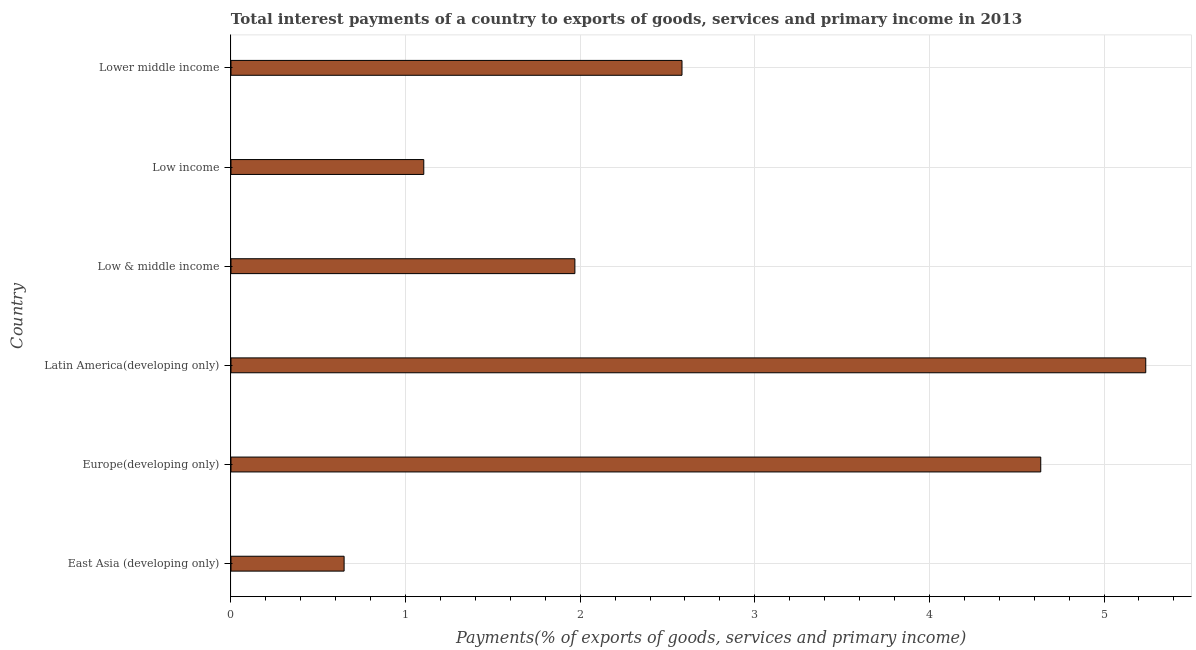Does the graph contain any zero values?
Your response must be concise. No. What is the title of the graph?
Offer a terse response. Total interest payments of a country to exports of goods, services and primary income in 2013. What is the label or title of the X-axis?
Provide a succinct answer. Payments(% of exports of goods, services and primary income). What is the label or title of the Y-axis?
Provide a short and direct response. Country. What is the total interest payments on external debt in Latin America(developing only)?
Keep it short and to the point. 5.24. Across all countries, what is the maximum total interest payments on external debt?
Make the answer very short. 5.24. Across all countries, what is the minimum total interest payments on external debt?
Your answer should be very brief. 0.65. In which country was the total interest payments on external debt maximum?
Your answer should be very brief. Latin America(developing only). In which country was the total interest payments on external debt minimum?
Ensure brevity in your answer.  East Asia (developing only). What is the sum of the total interest payments on external debt?
Provide a succinct answer. 16.18. What is the difference between the total interest payments on external debt in East Asia (developing only) and Latin America(developing only)?
Your answer should be very brief. -4.59. What is the average total interest payments on external debt per country?
Your response must be concise. 2.7. What is the median total interest payments on external debt?
Keep it short and to the point. 2.28. What is the ratio of the total interest payments on external debt in East Asia (developing only) to that in Latin America(developing only)?
Provide a succinct answer. 0.12. Is the difference between the total interest payments on external debt in East Asia (developing only) and Lower middle income greater than the difference between any two countries?
Provide a short and direct response. No. What is the difference between the highest and the second highest total interest payments on external debt?
Ensure brevity in your answer.  0.6. Is the sum of the total interest payments on external debt in Latin America(developing only) and Low income greater than the maximum total interest payments on external debt across all countries?
Your answer should be compact. Yes. What is the difference between the highest and the lowest total interest payments on external debt?
Offer a terse response. 4.59. How many bars are there?
Provide a succinct answer. 6. Are all the bars in the graph horizontal?
Offer a very short reply. Yes. How many countries are there in the graph?
Offer a very short reply. 6. What is the difference between two consecutive major ticks on the X-axis?
Give a very brief answer. 1. What is the Payments(% of exports of goods, services and primary income) of East Asia (developing only)?
Offer a very short reply. 0.65. What is the Payments(% of exports of goods, services and primary income) in Europe(developing only)?
Provide a succinct answer. 4.64. What is the Payments(% of exports of goods, services and primary income) in Latin America(developing only)?
Keep it short and to the point. 5.24. What is the Payments(% of exports of goods, services and primary income) of Low & middle income?
Ensure brevity in your answer.  1.97. What is the Payments(% of exports of goods, services and primary income) of Low income?
Provide a succinct answer. 1.1. What is the Payments(% of exports of goods, services and primary income) of Lower middle income?
Offer a very short reply. 2.58. What is the difference between the Payments(% of exports of goods, services and primary income) in East Asia (developing only) and Europe(developing only)?
Give a very brief answer. -3.99. What is the difference between the Payments(% of exports of goods, services and primary income) in East Asia (developing only) and Latin America(developing only)?
Your answer should be compact. -4.59. What is the difference between the Payments(% of exports of goods, services and primary income) in East Asia (developing only) and Low & middle income?
Your answer should be very brief. -1.32. What is the difference between the Payments(% of exports of goods, services and primary income) in East Asia (developing only) and Low income?
Keep it short and to the point. -0.46. What is the difference between the Payments(% of exports of goods, services and primary income) in East Asia (developing only) and Lower middle income?
Offer a very short reply. -1.94. What is the difference between the Payments(% of exports of goods, services and primary income) in Europe(developing only) and Latin America(developing only)?
Provide a short and direct response. -0.6. What is the difference between the Payments(% of exports of goods, services and primary income) in Europe(developing only) and Low & middle income?
Your response must be concise. 2.67. What is the difference between the Payments(% of exports of goods, services and primary income) in Europe(developing only) and Low income?
Your answer should be very brief. 3.53. What is the difference between the Payments(% of exports of goods, services and primary income) in Europe(developing only) and Lower middle income?
Ensure brevity in your answer.  2.05. What is the difference between the Payments(% of exports of goods, services and primary income) in Latin America(developing only) and Low & middle income?
Give a very brief answer. 3.27. What is the difference between the Payments(% of exports of goods, services and primary income) in Latin America(developing only) and Low income?
Offer a very short reply. 4.13. What is the difference between the Payments(% of exports of goods, services and primary income) in Latin America(developing only) and Lower middle income?
Offer a terse response. 2.66. What is the difference between the Payments(% of exports of goods, services and primary income) in Low & middle income and Low income?
Provide a short and direct response. 0.87. What is the difference between the Payments(% of exports of goods, services and primary income) in Low & middle income and Lower middle income?
Your answer should be very brief. -0.61. What is the difference between the Payments(% of exports of goods, services and primary income) in Low income and Lower middle income?
Your response must be concise. -1.48. What is the ratio of the Payments(% of exports of goods, services and primary income) in East Asia (developing only) to that in Europe(developing only)?
Make the answer very short. 0.14. What is the ratio of the Payments(% of exports of goods, services and primary income) in East Asia (developing only) to that in Latin America(developing only)?
Ensure brevity in your answer.  0.12. What is the ratio of the Payments(% of exports of goods, services and primary income) in East Asia (developing only) to that in Low & middle income?
Keep it short and to the point. 0.33. What is the ratio of the Payments(% of exports of goods, services and primary income) in East Asia (developing only) to that in Low income?
Your answer should be compact. 0.59. What is the ratio of the Payments(% of exports of goods, services and primary income) in East Asia (developing only) to that in Lower middle income?
Ensure brevity in your answer.  0.25. What is the ratio of the Payments(% of exports of goods, services and primary income) in Europe(developing only) to that in Latin America(developing only)?
Provide a succinct answer. 0.89. What is the ratio of the Payments(% of exports of goods, services and primary income) in Europe(developing only) to that in Low & middle income?
Give a very brief answer. 2.35. What is the ratio of the Payments(% of exports of goods, services and primary income) in Europe(developing only) to that in Low income?
Your response must be concise. 4.2. What is the ratio of the Payments(% of exports of goods, services and primary income) in Europe(developing only) to that in Lower middle income?
Your answer should be compact. 1.79. What is the ratio of the Payments(% of exports of goods, services and primary income) in Latin America(developing only) to that in Low & middle income?
Provide a short and direct response. 2.66. What is the ratio of the Payments(% of exports of goods, services and primary income) in Latin America(developing only) to that in Low income?
Ensure brevity in your answer.  4.74. What is the ratio of the Payments(% of exports of goods, services and primary income) in Latin America(developing only) to that in Lower middle income?
Your answer should be very brief. 2.03. What is the ratio of the Payments(% of exports of goods, services and primary income) in Low & middle income to that in Low income?
Offer a terse response. 1.78. What is the ratio of the Payments(% of exports of goods, services and primary income) in Low & middle income to that in Lower middle income?
Provide a succinct answer. 0.76. What is the ratio of the Payments(% of exports of goods, services and primary income) in Low income to that in Lower middle income?
Offer a very short reply. 0.43. 